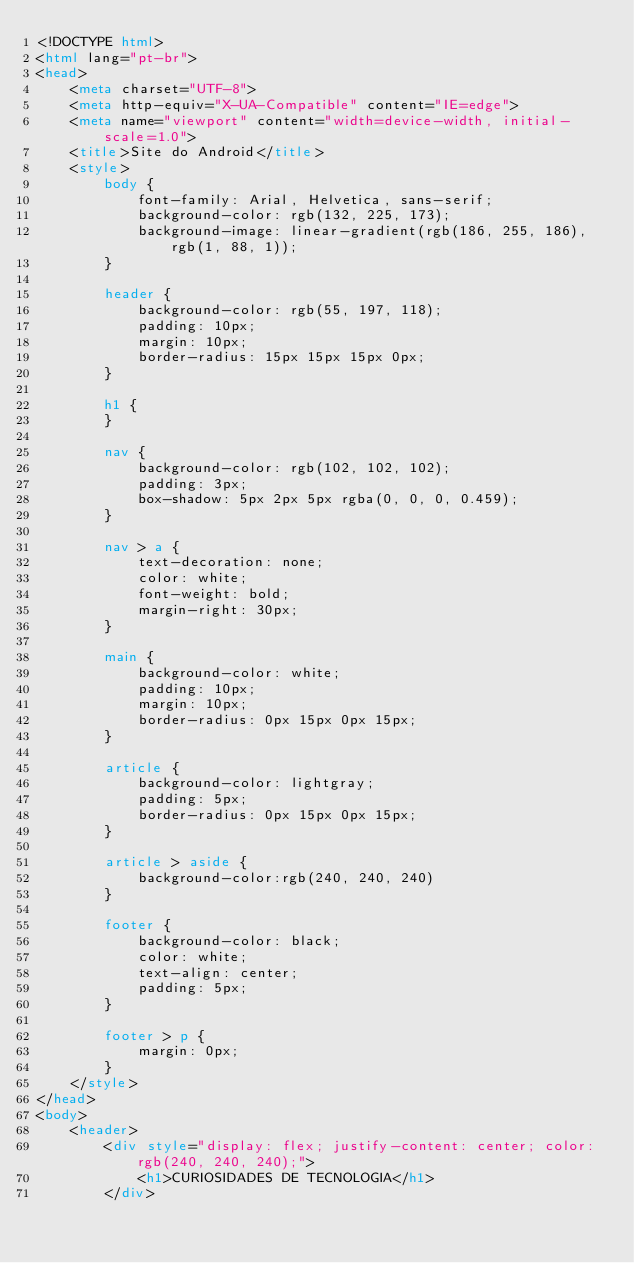Convert code to text. <code><loc_0><loc_0><loc_500><loc_500><_HTML_><!DOCTYPE html>
<html lang="pt-br">
<head>
    <meta charset="UTF-8">
    <meta http-equiv="X-UA-Compatible" content="IE=edge">
    <meta name="viewport" content="width=device-width, initial-scale=1.0">
    <title>Site do Android</title>
    <style>
        body {
            font-family: Arial, Helvetica, sans-serif;
            background-color: rgb(132, 225, 173);
            background-image: linear-gradient(rgb(186, 255, 186), rgb(1, 88, 1));
        }
        
        header {
            background-color: rgb(55, 197, 118);
            padding: 10px;
            margin: 10px;
            border-radius: 15px 15px 15px 0px;
        }

        h1 {
        }

        nav {
            background-color: rgb(102, 102, 102);
            padding: 3px;
            box-shadow: 5px 2px 5px rgba(0, 0, 0, 0.459);
        }

        nav > a {
            text-decoration: none;
            color: white;
            font-weight: bold;
            margin-right: 30px;
        }

        main {
            background-color: white;
            padding: 10px;
            margin: 10px;
            border-radius: 0px 15px 0px 15px;
        }

        article {
            background-color: lightgray;
            padding: 5px;
            border-radius: 0px 15px 0px 15px;
        }

        article > aside {
            background-color:rgb(240, 240, 240)
        }

        footer {
            background-color: black;
            color: white;
            text-align: center;
            padding: 5px;
        }

        footer > p {
            margin: 0px;
        }
    </style>
</head>
<body>
    <header>
        <div style="display: flex; justify-content: center; color: rgb(240, 240, 240);">
            <h1>CURIOSIDADES DE TECNOLOGIA</h1>
        </div></code> 